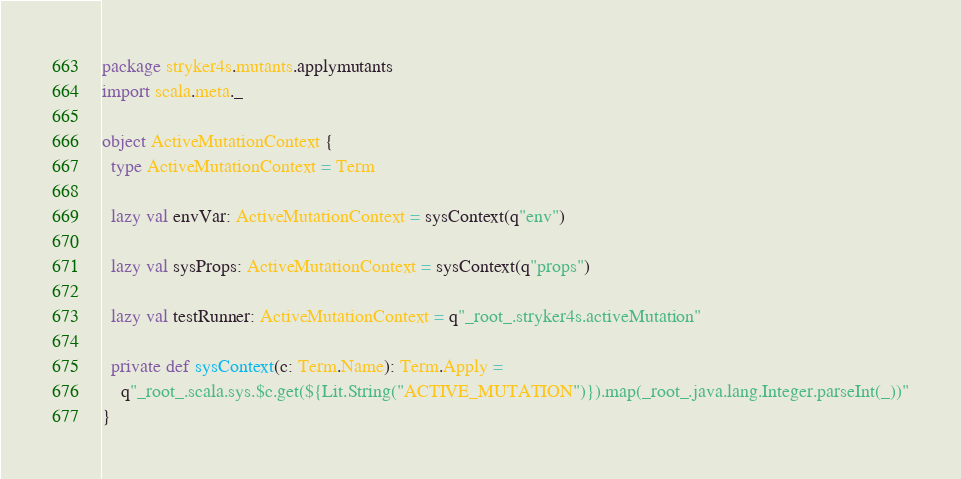<code> <loc_0><loc_0><loc_500><loc_500><_Scala_>package stryker4s.mutants.applymutants
import scala.meta._

object ActiveMutationContext {
  type ActiveMutationContext = Term

  lazy val envVar: ActiveMutationContext = sysContext(q"env")

  lazy val sysProps: ActiveMutationContext = sysContext(q"props")

  lazy val testRunner: ActiveMutationContext = q"_root_.stryker4s.activeMutation"

  private def sysContext(c: Term.Name): Term.Apply =
    q"_root_.scala.sys.$c.get(${Lit.String("ACTIVE_MUTATION")}).map(_root_.java.lang.Integer.parseInt(_))"
}
</code> 